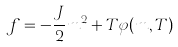Convert formula to latex. <formula><loc_0><loc_0><loc_500><loc_500>f = - \frac { J } { 2 } m ^ { 2 } + T \varphi ( m , T )</formula> 